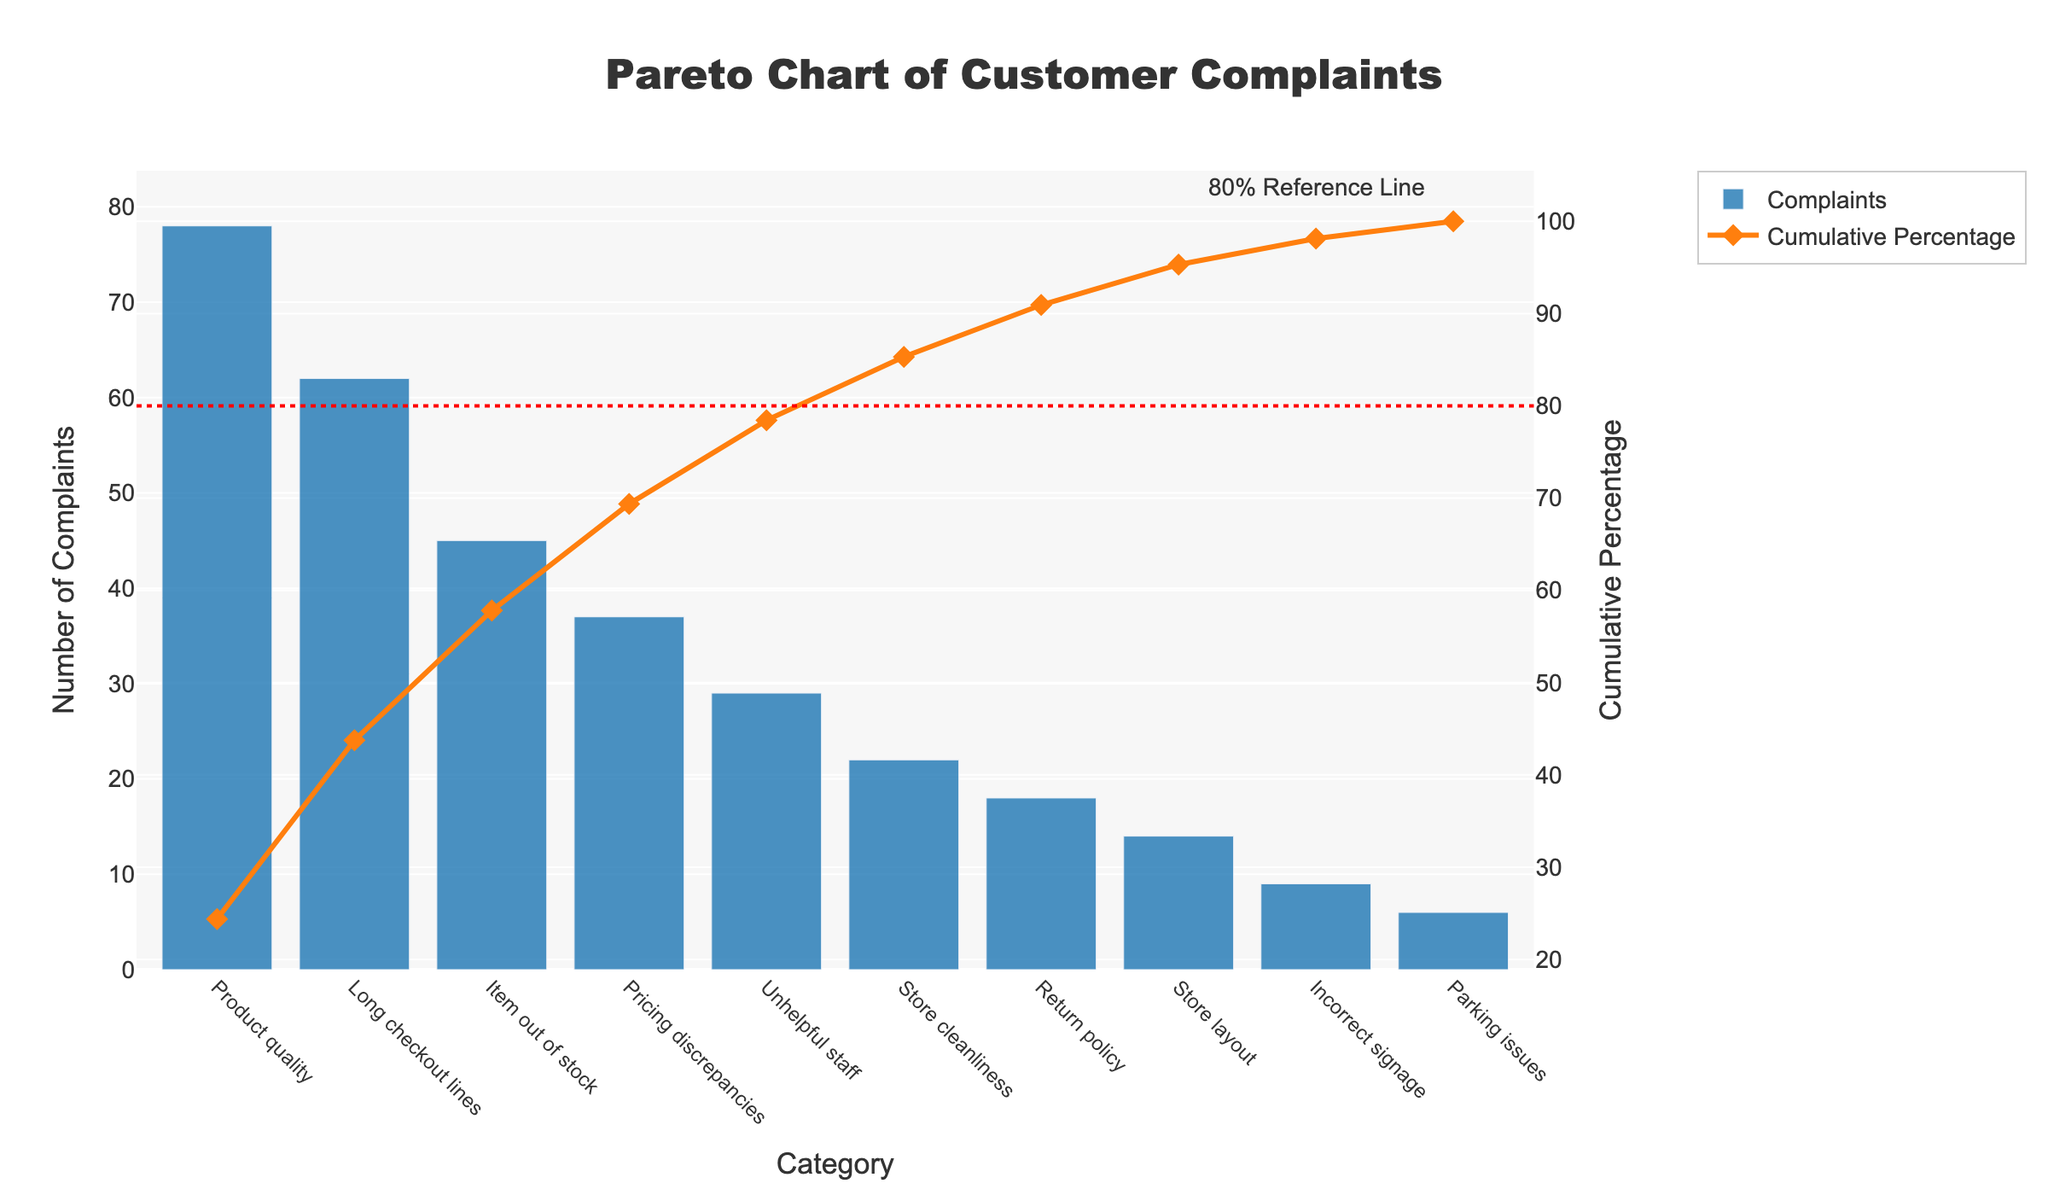What is the title of the figure? The title is typically located at the top center of the chart. Here, it reads "Pareto Chart of Customer Complaints".
Answer: Pareto Chart of Customer Complaints Which category has the highest number of complaints? By looking at the heights of the bars, the tallest bar represents the category with the highest number of complaints. Here, "Product quality" has the highest number of complaints.
Answer: Product quality What is the number of complaints in the "Item out of stock" category? The height of the bar labeled "Item out of stock" indicates the number of complaints. The bar reaches up to 45 on the y-axis.
Answer: 45 What cumulative percentage is reached after the second category? After identifying the first two categories ("Product quality" and "Long checkout lines"), sum up their complaints (78 + 62 = 140). The cumulative percentage for 140 complaints can be observed on the secondary y-axis (approximately 56%).
Answer: Approximately 56% How many categories must be addressed to resolve over 80% of complaints? By observing where the cumulative percentage line crosses the 80% reference line, we can count the number of categories required. Here, it seems to cross at approximately the 5th category.
Answer: 5 Which category has fewer complaints: "Store layout" or "Return policy"? Compare the heights of the bars for "Store layout" and "Return policy". "Store layout" has 14 complaints, while "Return policy" has 18. Therefore, "Store layout" has fewer complaints.
Answer: Store layout What is the cumulative percentage after including the "Unhelpful staff" category? Sum up the complaints from "Product quality", "Long checkout lines", "Item out of stock", "Pricing discrepancies", and "Unhelpful staff" (78 + 62 + 45 + 37 + 29 = 251). Then, find where this cumulative number lies on the cumulative percentage line (approximately 85%).
Answer: Approximately 85% Which category is contributing the least to the cumulative percentage of complaints? The shortest bar represents the category with the least number of complaints, which is "Parking issues" with 6 complaints.
Answer: Parking issues 